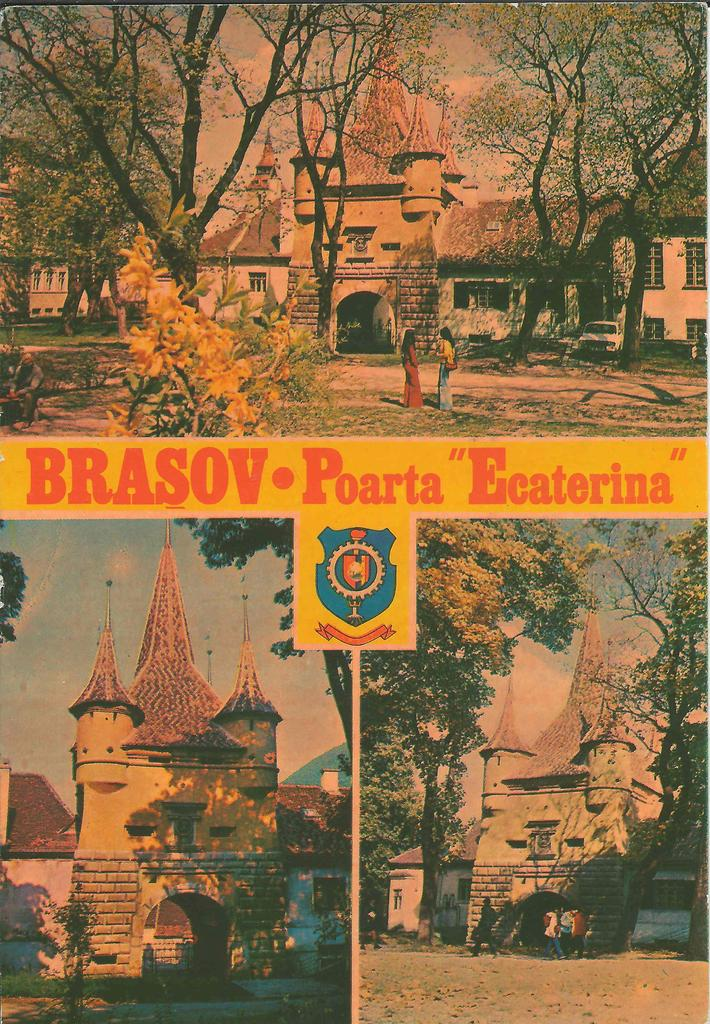What types of structures are present in the image? There are buildings in the image. What natural elements can be seen in the image? There are trees and plants in the image. What is happening on the road in the image? There is a crowd on the road in the image. What is the symbolic object visible in the image? There is a flag in the image. What else is present on the road in the image? There are vehicles in the image. What part of the natural environment is visible in the image? The sky is visible in the image. Can you tell me how many kitties are sitting on the fruit in the image? There are no kitties or fruit present in the image. What color are the eyes of the person in the image? There are no people visible in the image, so it is not possible to determine the color of their eyes. 